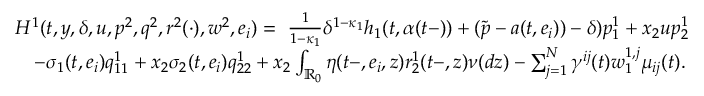Convert formula to latex. <formula><loc_0><loc_0><loc_500><loc_500>\begin{array} { r l } & { H ^ { 1 } ( t , y , \delta , u , p ^ { 2 } , q ^ { 2 } , r ^ { 2 } ( \cdot ) , w ^ { 2 } , e _ { i } ) = \ \frac { 1 } { 1 - \kappa _ { 1 } } \delta ^ { 1 - \kappa _ { 1 } } h _ { 1 } ( t , \alpha ( t - ) ) + ( \tilde { p } - a ( t , e _ { i } ) ) - \delta ) p _ { 1 } ^ { 1 } + x _ { 2 } u p _ { 2 } ^ { 1 } } \\ & { \quad - \sigma _ { 1 } ( t , e _ { i } ) q _ { 1 1 } ^ { 1 } + x _ { 2 } \sigma _ { 2 } ( t , e _ { i } ) q _ { 2 2 } ^ { 1 } + x _ { 2 } \int _ { \mathbb { R } _ { 0 } } \eta ( t - , e _ { i } , z ) r _ { 2 } ^ { 1 } ( t - , z ) \nu ( d z ) - \sum _ { j = 1 } ^ { N } \gamma ^ { i j } ( t ) w _ { 1 } ^ { 1 , j } \mu _ { i j } ( t ) . } \end{array}</formula> 